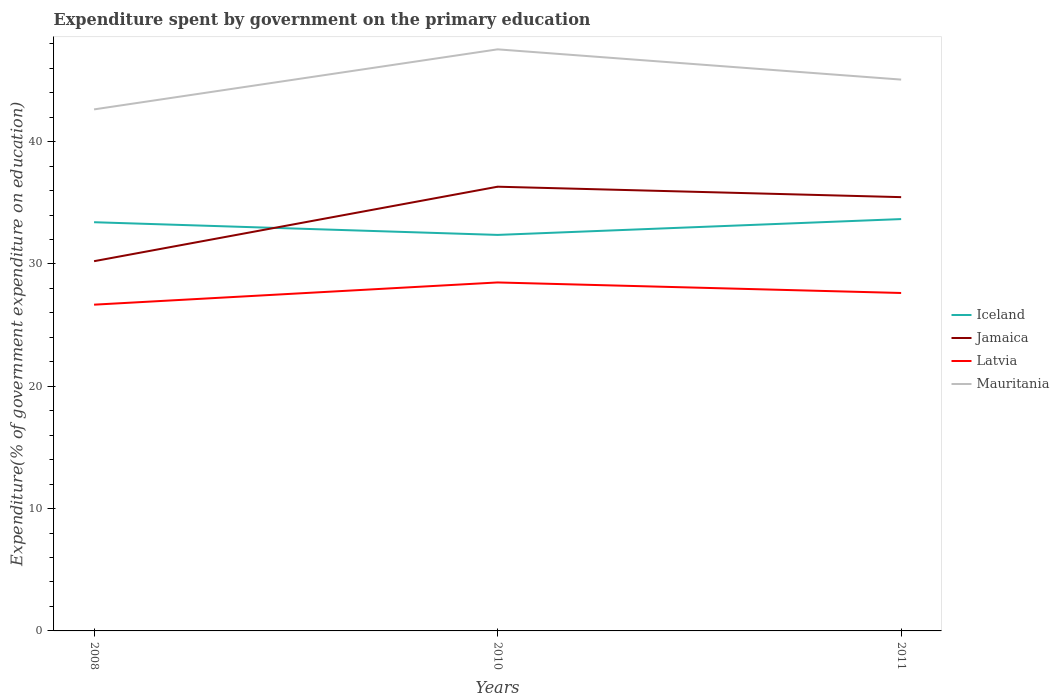Is the number of lines equal to the number of legend labels?
Ensure brevity in your answer.  Yes. Across all years, what is the maximum expenditure spent by government on the primary education in Mauritania?
Offer a very short reply. 42.64. What is the total expenditure spent by government on the primary education in Iceland in the graph?
Offer a terse response. 1.04. What is the difference between the highest and the second highest expenditure spent by government on the primary education in Latvia?
Offer a very short reply. 1.82. How many lines are there?
Your answer should be very brief. 4. What is the difference between two consecutive major ticks on the Y-axis?
Your answer should be very brief. 10. Are the values on the major ticks of Y-axis written in scientific E-notation?
Give a very brief answer. No. Does the graph contain grids?
Offer a terse response. No. Where does the legend appear in the graph?
Offer a terse response. Center right. How many legend labels are there?
Provide a succinct answer. 4. How are the legend labels stacked?
Your response must be concise. Vertical. What is the title of the graph?
Make the answer very short. Expenditure spent by government on the primary education. Does "East Asia (developing only)" appear as one of the legend labels in the graph?
Make the answer very short. No. What is the label or title of the X-axis?
Offer a terse response. Years. What is the label or title of the Y-axis?
Your answer should be compact. Expenditure(% of government expenditure on education). What is the Expenditure(% of government expenditure on education) in Iceland in 2008?
Provide a short and direct response. 33.41. What is the Expenditure(% of government expenditure on education) of Jamaica in 2008?
Your response must be concise. 30.23. What is the Expenditure(% of government expenditure on education) in Latvia in 2008?
Your response must be concise. 26.67. What is the Expenditure(% of government expenditure on education) of Mauritania in 2008?
Make the answer very short. 42.64. What is the Expenditure(% of government expenditure on education) of Iceland in 2010?
Provide a succinct answer. 32.38. What is the Expenditure(% of government expenditure on education) in Jamaica in 2010?
Your answer should be very brief. 36.32. What is the Expenditure(% of government expenditure on education) in Latvia in 2010?
Provide a short and direct response. 28.49. What is the Expenditure(% of government expenditure on education) of Mauritania in 2010?
Make the answer very short. 47.55. What is the Expenditure(% of government expenditure on education) in Iceland in 2011?
Make the answer very short. 33.67. What is the Expenditure(% of government expenditure on education) of Jamaica in 2011?
Offer a terse response. 35.46. What is the Expenditure(% of government expenditure on education) in Latvia in 2011?
Keep it short and to the point. 27.63. What is the Expenditure(% of government expenditure on education) in Mauritania in 2011?
Your answer should be very brief. 45.07. Across all years, what is the maximum Expenditure(% of government expenditure on education) of Iceland?
Your answer should be compact. 33.67. Across all years, what is the maximum Expenditure(% of government expenditure on education) of Jamaica?
Offer a very short reply. 36.32. Across all years, what is the maximum Expenditure(% of government expenditure on education) in Latvia?
Your answer should be compact. 28.49. Across all years, what is the maximum Expenditure(% of government expenditure on education) in Mauritania?
Your answer should be very brief. 47.55. Across all years, what is the minimum Expenditure(% of government expenditure on education) in Iceland?
Your response must be concise. 32.38. Across all years, what is the minimum Expenditure(% of government expenditure on education) in Jamaica?
Offer a terse response. 30.23. Across all years, what is the minimum Expenditure(% of government expenditure on education) of Latvia?
Your answer should be compact. 26.67. Across all years, what is the minimum Expenditure(% of government expenditure on education) in Mauritania?
Your answer should be compact. 42.64. What is the total Expenditure(% of government expenditure on education) in Iceland in the graph?
Give a very brief answer. 99.46. What is the total Expenditure(% of government expenditure on education) of Jamaica in the graph?
Your answer should be compact. 102.01. What is the total Expenditure(% of government expenditure on education) of Latvia in the graph?
Make the answer very short. 82.79. What is the total Expenditure(% of government expenditure on education) of Mauritania in the graph?
Make the answer very short. 135.26. What is the difference between the Expenditure(% of government expenditure on education) of Iceland in 2008 and that in 2010?
Provide a succinct answer. 1.04. What is the difference between the Expenditure(% of government expenditure on education) of Jamaica in 2008 and that in 2010?
Provide a succinct answer. -6.09. What is the difference between the Expenditure(% of government expenditure on education) in Latvia in 2008 and that in 2010?
Ensure brevity in your answer.  -1.82. What is the difference between the Expenditure(% of government expenditure on education) of Mauritania in 2008 and that in 2010?
Your answer should be very brief. -4.91. What is the difference between the Expenditure(% of government expenditure on education) in Iceland in 2008 and that in 2011?
Make the answer very short. -0.26. What is the difference between the Expenditure(% of government expenditure on education) in Jamaica in 2008 and that in 2011?
Give a very brief answer. -5.24. What is the difference between the Expenditure(% of government expenditure on education) in Latvia in 2008 and that in 2011?
Keep it short and to the point. -0.96. What is the difference between the Expenditure(% of government expenditure on education) in Mauritania in 2008 and that in 2011?
Your answer should be very brief. -2.44. What is the difference between the Expenditure(% of government expenditure on education) in Iceland in 2010 and that in 2011?
Your response must be concise. -1.29. What is the difference between the Expenditure(% of government expenditure on education) of Jamaica in 2010 and that in 2011?
Ensure brevity in your answer.  0.85. What is the difference between the Expenditure(% of government expenditure on education) of Latvia in 2010 and that in 2011?
Give a very brief answer. 0.86. What is the difference between the Expenditure(% of government expenditure on education) of Mauritania in 2010 and that in 2011?
Your answer should be very brief. 2.47. What is the difference between the Expenditure(% of government expenditure on education) in Iceland in 2008 and the Expenditure(% of government expenditure on education) in Jamaica in 2010?
Give a very brief answer. -2.9. What is the difference between the Expenditure(% of government expenditure on education) of Iceland in 2008 and the Expenditure(% of government expenditure on education) of Latvia in 2010?
Your answer should be very brief. 4.92. What is the difference between the Expenditure(% of government expenditure on education) in Iceland in 2008 and the Expenditure(% of government expenditure on education) in Mauritania in 2010?
Your answer should be compact. -14.13. What is the difference between the Expenditure(% of government expenditure on education) of Jamaica in 2008 and the Expenditure(% of government expenditure on education) of Latvia in 2010?
Provide a short and direct response. 1.74. What is the difference between the Expenditure(% of government expenditure on education) of Jamaica in 2008 and the Expenditure(% of government expenditure on education) of Mauritania in 2010?
Give a very brief answer. -17.32. What is the difference between the Expenditure(% of government expenditure on education) of Latvia in 2008 and the Expenditure(% of government expenditure on education) of Mauritania in 2010?
Your response must be concise. -20.87. What is the difference between the Expenditure(% of government expenditure on education) in Iceland in 2008 and the Expenditure(% of government expenditure on education) in Jamaica in 2011?
Make the answer very short. -2.05. What is the difference between the Expenditure(% of government expenditure on education) of Iceland in 2008 and the Expenditure(% of government expenditure on education) of Latvia in 2011?
Make the answer very short. 5.78. What is the difference between the Expenditure(% of government expenditure on education) of Iceland in 2008 and the Expenditure(% of government expenditure on education) of Mauritania in 2011?
Give a very brief answer. -11.66. What is the difference between the Expenditure(% of government expenditure on education) of Jamaica in 2008 and the Expenditure(% of government expenditure on education) of Latvia in 2011?
Your answer should be compact. 2.6. What is the difference between the Expenditure(% of government expenditure on education) in Jamaica in 2008 and the Expenditure(% of government expenditure on education) in Mauritania in 2011?
Your response must be concise. -14.85. What is the difference between the Expenditure(% of government expenditure on education) of Latvia in 2008 and the Expenditure(% of government expenditure on education) of Mauritania in 2011?
Provide a succinct answer. -18.4. What is the difference between the Expenditure(% of government expenditure on education) in Iceland in 2010 and the Expenditure(% of government expenditure on education) in Jamaica in 2011?
Offer a very short reply. -3.09. What is the difference between the Expenditure(% of government expenditure on education) of Iceland in 2010 and the Expenditure(% of government expenditure on education) of Latvia in 2011?
Keep it short and to the point. 4.75. What is the difference between the Expenditure(% of government expenditure on education) in Iceland in 2010 and the Expenditure(% of government expenditure on education) in Mauritania in 2011?
Make the answer very short. -12.7. What is the difference between the Expenditure(% of government expenditure on education) in Jamaica in 2010 and the Expenditure(% of government expenditure on education) in Latvia in 2011?
Provide a short and direct response. 8.69. What is the difference between the Expenditure(% of government expenditure on education) of Jamaica in 2010 and the Expenditure(% of government expenditure on education) of Mauritania in 2011?
Provide a short and direct response. -8.76. What is the difference between the Expenditure(% of government expenditure on education) of Latvia in 2010 and the Expenditure(% of government expenditure on education) of Mauritania in 2011?
Your answer should be very brief. -16.58. What is the average Expenditure(% of government expenditure on education) of Iceland per year?
Give a very brief answer. 33.15. What is the average Expenditure(% of government expenditure on education) in Jamaica per year?
Keep it short and to the point. 34. What is the average Expenditure(% of government expenditure on education) in Latvia per year?
Your answer should be very brief. 27.6. What is the average Expenditure(% of government expenditure on education) in Mauritania per year?
Offer a very short reply. 45.09. In the year 2008, what is the difference between the Expenditure(% of government expenditure on education) of Iceland and Expenditure(% of government expenditure on education) of Jamaica?
Give a very brief answer. 3.19. In the year 2008, what is the difference between the Expenditure(% of government expenditure on education) of Iceland and Expenditure(% of government expenditure on education) of Latvia?
Your answer should be compact. 6.74. In the year 2008, what is the difference between the Expenditure(% of government expenditure on education) in Iceland and Expenditure(% of government expenditure on education) in Mauritania?
Your response must be concise. -9.22. In the year 2008, what is the difference between the Expenditure(% of government expenditure on education) in Jamaica and Expenditure(% of government expenditure on education) in Latvia?
Offer a terse response. 3.55. In the year 2008, what is the difference between the Expenditure(% of government expenditure on education) in Jamaica and Expenditure(% of government expenditure on education) in Mauritania?
Your response must be concise. -12.41. In the year 2008, what is the difference between the Expenditure(% of government expenditure on education) in Latvia and Expenditure(% of government expenditure on education) in Mauritania?
Give a very brief answer. -15.96. In the year 2010, what is the difference between the Expenditure(% of government expenditure on education) in Iceland and Expenditure(% of government expenditure on education) in Jamaica?
Give a very brief answer. -3.94. In the year 2010, what is the difference between the Expenditure(% of government expenditure on education) of Iceland and Expenditure(% of government expenditure on education) of Latvia?
Give a very brief answer. 3.89. In the year 2010, what is the difference between the Expenditure(% of government expenditure on education) of Iceland and Expenditure(% of government expenditure on education) of Mauritania?
Give a very brief answer. -15.17. In the year 2010, what is the difference between the Expenditure(% of government expenditure on education) of Jamaica and Expenditure(% of government expenditure on education) of Latvia?
Your answer should be compact. 7.83. In the year 2010, what is the difference between the Expenditure(% of government expenditure on education) of Jamaica and Expenditure(% of government expenditure on education) of Mauritania?
Give a very brief answer. -11.23. In the year 2010, what is the difference between the Expenditure(% of government expenditure on education) in Latvia and Expenditure(% of government expenditure on education) in Mauritania?
Ensure brevity in your answer.  -19.06. In the year 2011, what is the difference between the Expenditure(% of government expenditure on education) of Iceland and Expenditure(% of government expenditure on education) of Jamaica?
Keep it short and to the point. -1.79. In the year 2011, what is the difference between the Expenditure(% of government expenditure on education) of Iceland and Expenditure(% of government expenditure on education) of Latvia?
Make the answer very short. 6.04. In the year 2011, what is the difference between the Expenditure(% of government expenditure on education) in Iceland and Expenditure(% of government expenditure on education) in Mauritania?
Provide a succinct answer. -11.4. In the year 2011, what is the difference between the Expenditure(% of government expenditure on education) in Jamaica and Expenditure(% of government expenditure on education) in Latvia?
Provide a short and direct response. 7.84. In the year 2011, what is the difference between the Expenditure(% of government expenditure on education) in Jamaica and Expenditure(% of government expenditure on education) in Mauritania?
Keep it short and to the point. -9.61. In the year 2011, what is the difference between the Expenditure(% of government expenditure on education) in Latvia and Expenditure(% of government expenditure on education) in Mauritania?
Offer a terse response. -17.45. What is the ratio of the Expenditure(% of government expenditure on education) of Iceland in 2008 to that in 2010?
Your response must be concise. 1.03. What is the ratio of the Expenditure(% of government expenditure on education) in Jamaica in 2008 to that in 2010?
Your answer should be compact. 0.83. What is the ratio of the Expenditure(% of government expenditure on education) in Latvia in 2008 to that in 2010?
Offer a very short reply. 0.94. What is the ratio of the Expenditure(% of government expenditure on education) in Mauritania in 2008 to that in 2010?
Ensure brevity in your answer.  0.9. What is the ratio of the Expenditure(% of government expenditure on education) of Jamaica in 2008 to that in 2011?
Make the answer very short. 0.85. What is the ratio of the Expenditure(% of government expenditure on education) in Latvia in 2008 to that in 2011?
Provide a short and direct response. 0.97. What is the ratio of the Expenditure(% of government expenditure on education) in Mauritania in 2008 to that in 2011?
Your answer should be very brief. 0.95. What is the ratio of the Expenditure(% of government expenditure on education) of Iceland in 2010 to that in 2011?
Your answer should be very brief. 0.96. What is the ratio of the Expenditure(% of government expenditure on education) in Jamaica in 2010 to that in 2011?
Make the answer very short. 1.02. What is the ratio of the Expenditure(% of government expenditure on education) of Latvia in 2010 to that in 2011?
Provide a short and direct response. 1.03. What is the ratio of the Expenditure(% of government expenditure on education) in Mauritania in 2010 to that in 2011?
Your answer should be very brief. 1.05. What is the difference between the highest and the second highest Expenditure(% of government expenditure on education) of Iceland?
Provide a short and direct response. 0.26. What is the difference between the highest and the second highest Expenditure(% of government expenditure on education) in Jamaica?
Provide a succinct answer. 0.85. What is the difference between the highest and the second highest Expenditure(% of government expenditure on education) of Latvia?
Give a very brief answer. 0.86. What is the difference between the highest and the second highest Expenditure(% of government expenditure on education) of Mauritania?
Ensure brevity in your answer.  2.47. What is the difference between the highest and the lowest Expenditure(% of government expenditure on education) in Iceland?
Your response must be concise. 1.29. What is the difference between the highest and the lowest Expenditure(% of government expenditure on education) of Jamaica?
Provide a succinct answer. 6.09. What is the difference between the highest and the lowest Expenditure(% of government expenditure on education) in Latvia?
Your response must be concise. 1.82. What is the difference between the highest and the lowest Expenditure(% of government expenditure on education) in Mauritania?
Provide a succinct answer. 4.91. 